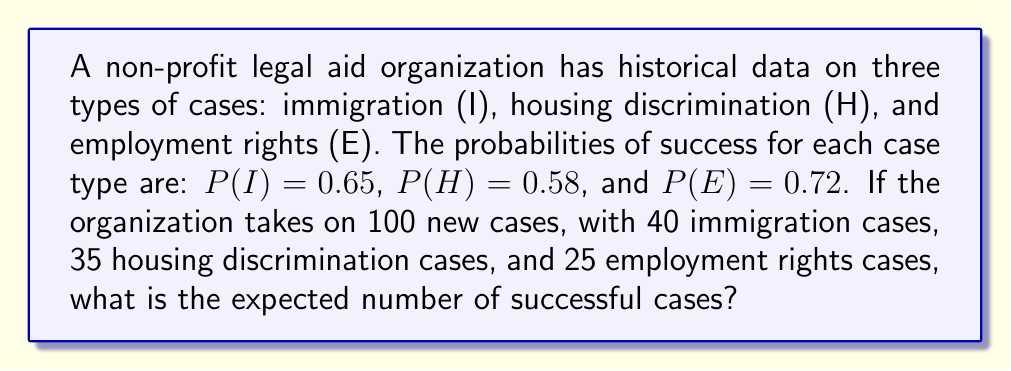Provide a solution to this math problem. To solve this problem, we'll follow these steps:

1) First, let's recall the formula for expected value:
   $E(X) = \sum_{i=1}^{n} x_i \cdot p_i$
   where $x_i$ is the number of cases of each type, and $p_i$ is the probability of success for each type.

2) Now, let's plug in our values:
   $E(X) = 40 \cdot P(I) + 35 \cdot P(H) + 25 \cdot P(E)$

3) Substitute the given probabilities:
   $E(X) = 40 \cdot 0.65 + 35 \cdot 0.58 + 25 \cdot 0.72$

4) Multiply each term:
   $E(X) = 26 + 20.3 + 18$

5) Sum up the results:
   $E(X) = 64.3$

Therefore, the expected number of successful cases is 64.3.
Answer: 64.3 cases 